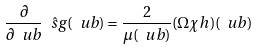<formula> <loc_0><loc_0><loc_500><loc_500>\frac { \partial } { \partial \ u b } \hat { \ s g } ( \ u b ) = \frac { 2 } { \mu ( \ u b ) } ( \Omega \chi h ) ( \ u b )</formula> 